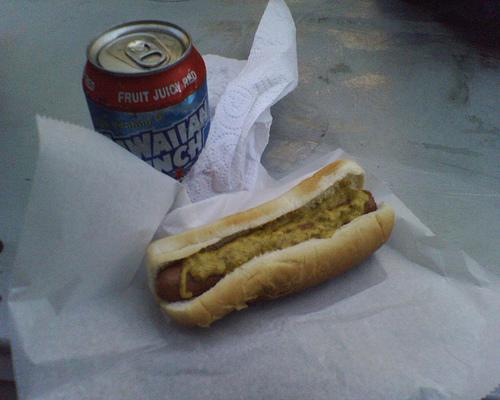Is this a Chicago style hot dog?
Quick response, please. No. Is the hotdog dressed?
Keep it brief. Yes. What is the hot dog sitting on top of?
Answer briefly. Paper. What drink is in the can?
Quick response, please. Hawaiian punch. Is the hot dog cooked?
Keep it brief. Yes. What is the beverage being consumed with this lunch?
Give a very brief answer. Hawaiian punch. 